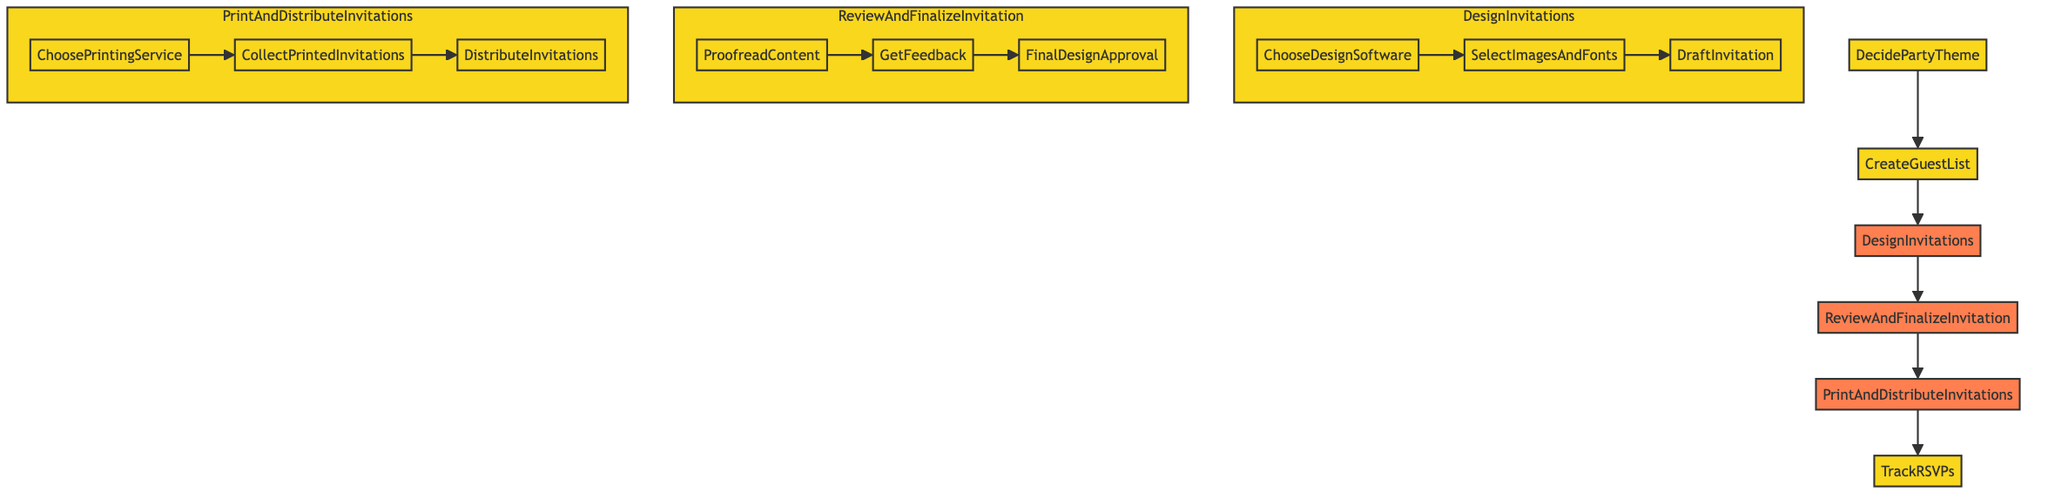What is the first step in the process? The diagram indicates that the first step in the process is "DecidePartyTheme." This is the initial action that sets the stage for the following activities.
Answer: DecidePartyTheme How many substeps are there in the "DesignInvitations" process? The "DesignInvitations" step includes three substeps: "ChooseDesignSoftware," "SelectImagesAndFonts," and "DraftInvitation." Counting these substeps yields a total of three.
Answer: 3 What follows after "CreateGuestList"? According to the flowchart, "DesignInvitations" directly follows "CreateGuestList" as the next step in the preparation process.
Answer: DesignInvitations Name one material that must be collected in the "PrintAndDistributeInvitations" phase. Within the "PrintAndDistributeInvitations" phase, the material that needs to be collected is the "PrintedInvitations." This step specifies that printed items are collected before distribution.
Answer: PrintedInvitations What is the final action in the process? The last action indicated in the process is "TrackRSVPs," which concludes the series of steps involved in preparation for the party.
Answer: TrackRSVPs Which step requires "GetFeedback"? The step that requires "GetFeedback" is "ReviewAndFinalizeInvitation." This indicates the necessity of obtaining input about the invitation before finalizing it.
Answer: ReviewAndFinalizeInvitation What is the purpose of the "ProofreadContent" substep? The "ProofreadContent" substep aims to ensure correctness in the invitation, checking for spelling and accuracy of details before moving on to feedback.
Answer: To check for spelling mistakes and accuracy of party details What is the connection between "DesignInvitations" and "ReviewAndFinalizeInvitation"? "DesignInvitations" leads directly into "ReviewAndFinalizeInvitation," indicating that once invitations are designed, they must be reviewed and finalized as the next essential step.
Answer: Leads directly into 